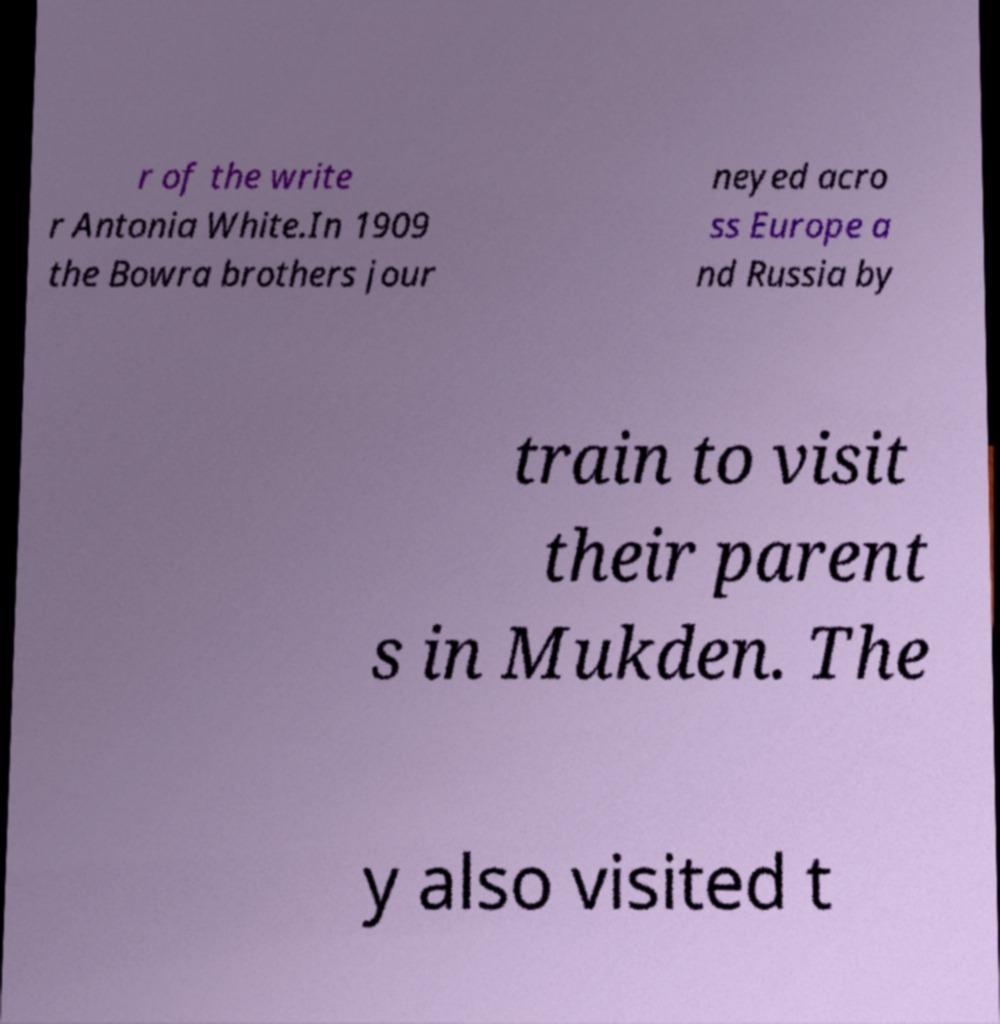Please read and relay the text visible in this image. What does it say? r of the write r Antonia White.In 1909 the Bowra brothers jour neyed acro ss Europe a nd Russia by train to visit their parent s in Mukden. The y also visited t 